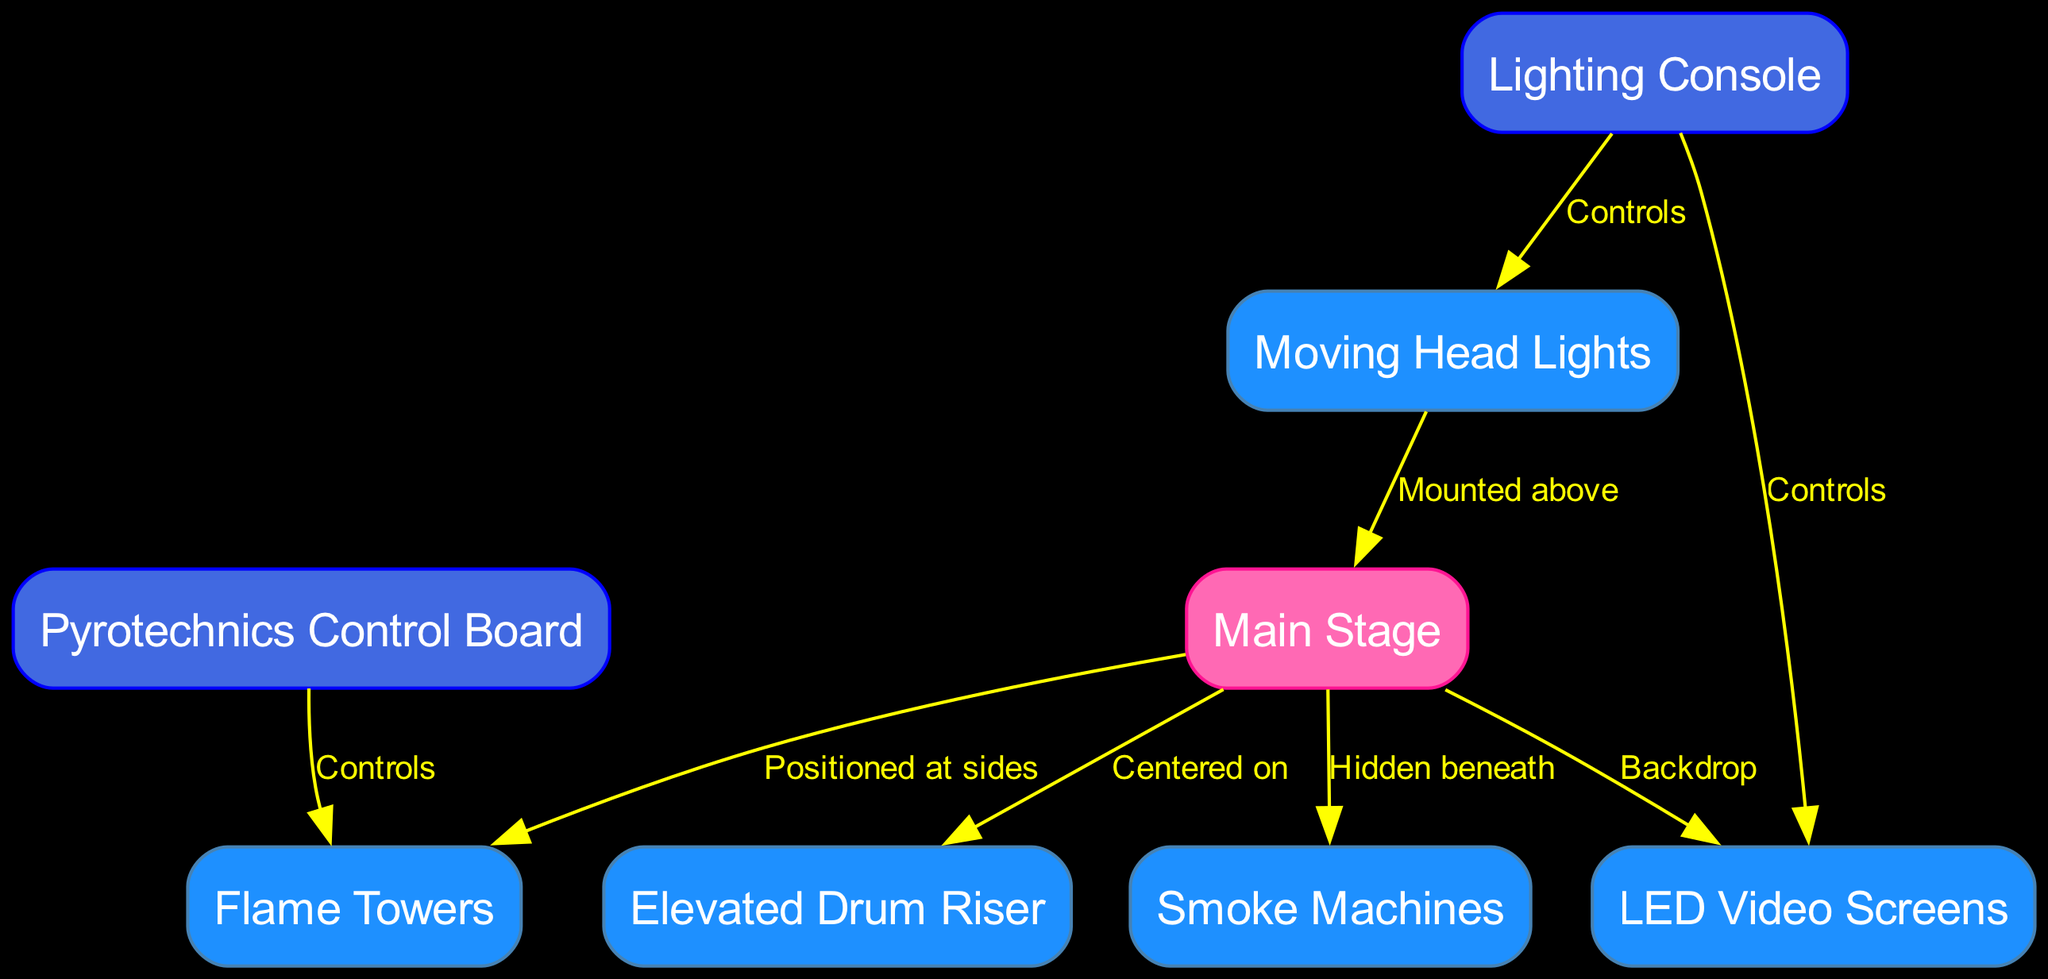What is the central element of the stage setup? The main stage is identified as the central element connecting various components, including the drum riser, flame towers, smoke machines, and LED screens.
Answer: Main Stage How many flame towers are positioned around the main stage? The diagram indicates that flame towers are positioned at the sides of the main stage, and since only one edge connects to the flame towers from the main stage, there are not multiple towers shown.
Answer: 1 Which component is controlled by the pyrotechnics control board? The edge from the pyrotechnics control board to the flame towers indicates it directly controls them, making the flame towers the only element specified for control by this component.
Answer: Flame Towers What is mounted above the main stage? The diagram shows that moving lights are mounted above the main stage, indicating their position in the overall configuration of the stage setup.
Answer: Moving Head Lights What is hidden beneath the main stage? The smoke machines are specifically noted as hidden beneath the main stage, providing an understanding of their strategic placement in the stage setup.
Answer: Smoke Machines How many edges connect the lighting console? The lighting console has edges connecting to both moving lights and LED screens, indicating it controls these two components, resulting in a total of two directed edges.
Answer: 2 Which node is centered on the main stage? The diagram shows that the drum riser is centered on the main stage, indicating its specific physical relationship to the main stage component.
Answer: Elevated Drum Riser What color represents the main stage in the diagram? The main stage is denoted with a pinkish shade (Hex: #FF69B4) in the diagram, as captured through its specific fill color assigned to that node.
Answer: Pink How do LED screens relate to the main stage? The diagram indicates that LED screens serve as a backdrop to the main stage, emphasizing their positioning behind it.
Answer: Backdrop 